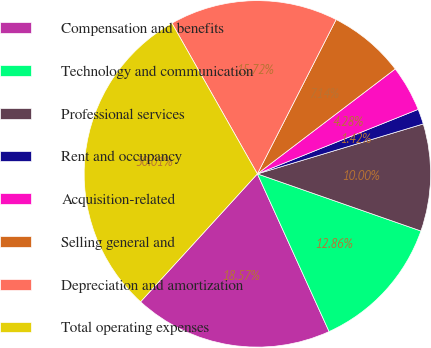<chart> <loc_0><loc_0><loc_500><loc_500><pie_chart><fcel>Compensation and benefits<fcel>Technology and communication<fcel>Professional services<fcel>Rent and occupancy<fcel>Acquisition-related<fcel>Selling general and<fcel>Depreciation and amortization<fcel>Total operating expenses<nl><fcel>18.57%<fcel>12.86%<fcel>10.0%<fcel>1.42%<fcel>4.28%<fcel>7.14%<fcel>15.72%<fcel>30.01%<nl></chart> 